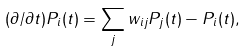Convert formula to latex. <formula><loc_0><loc_0><loc_500><loc_500>( \partial / { \partial t } ) P _ { i } ( t ) = \sum _ { j } w _ { i j } P _ { j } ( t ) - P _ { i } ( t ) ,</formula> 